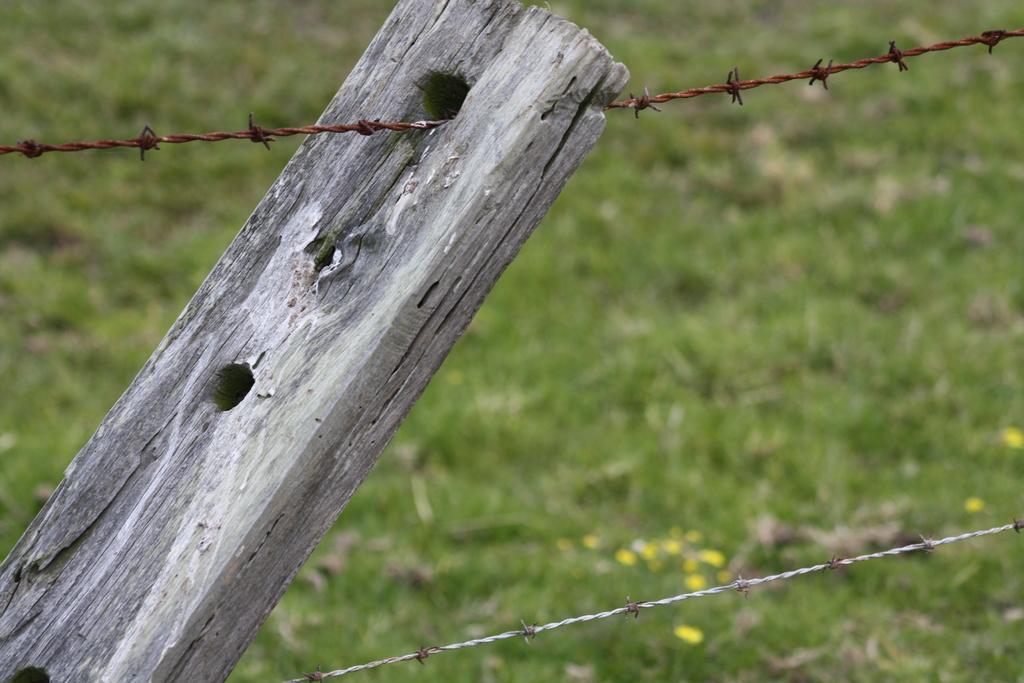Could you give a brief overview of what you see in this image? In this image there is a wooden stick and metal fence, behind them there's grass on the surface. 